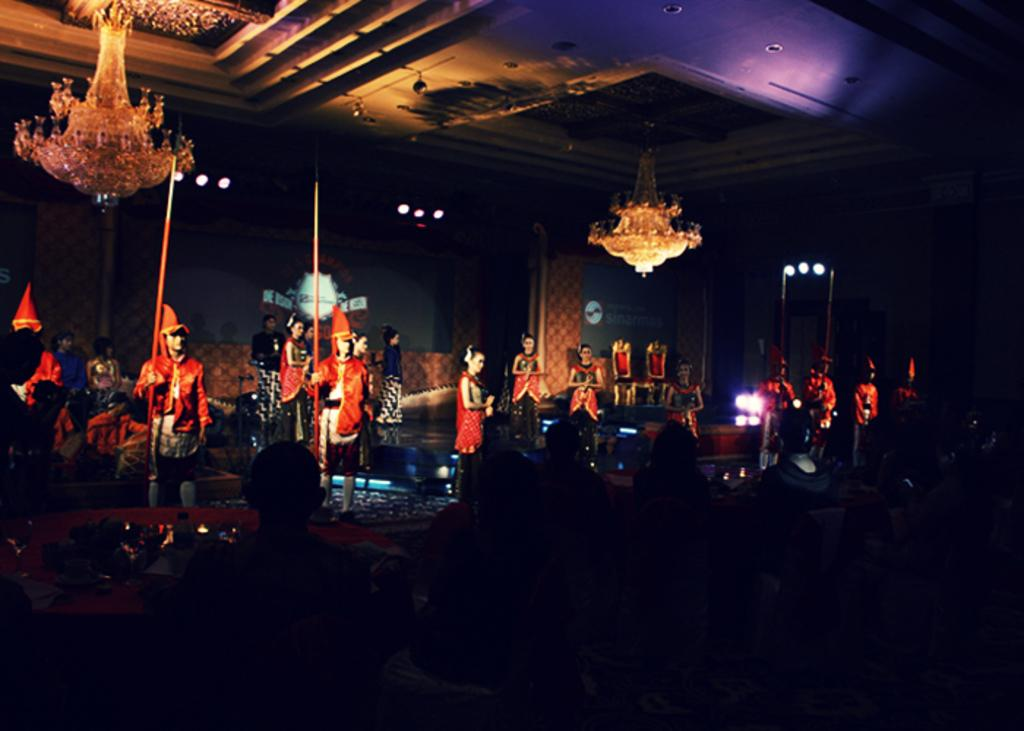What is happening in the image? There is a show happening in the image. How are people reacting to the show? People are sitting and watching the show. What can be seen hanging from the roof in the image? There are two chandeliers attached to the roof. Can you see a guitar being played by someone in the image? There is no guitar is no guitar visible in the image. What type of flower is being used as a prop in the show? There is no flower present in the image. 